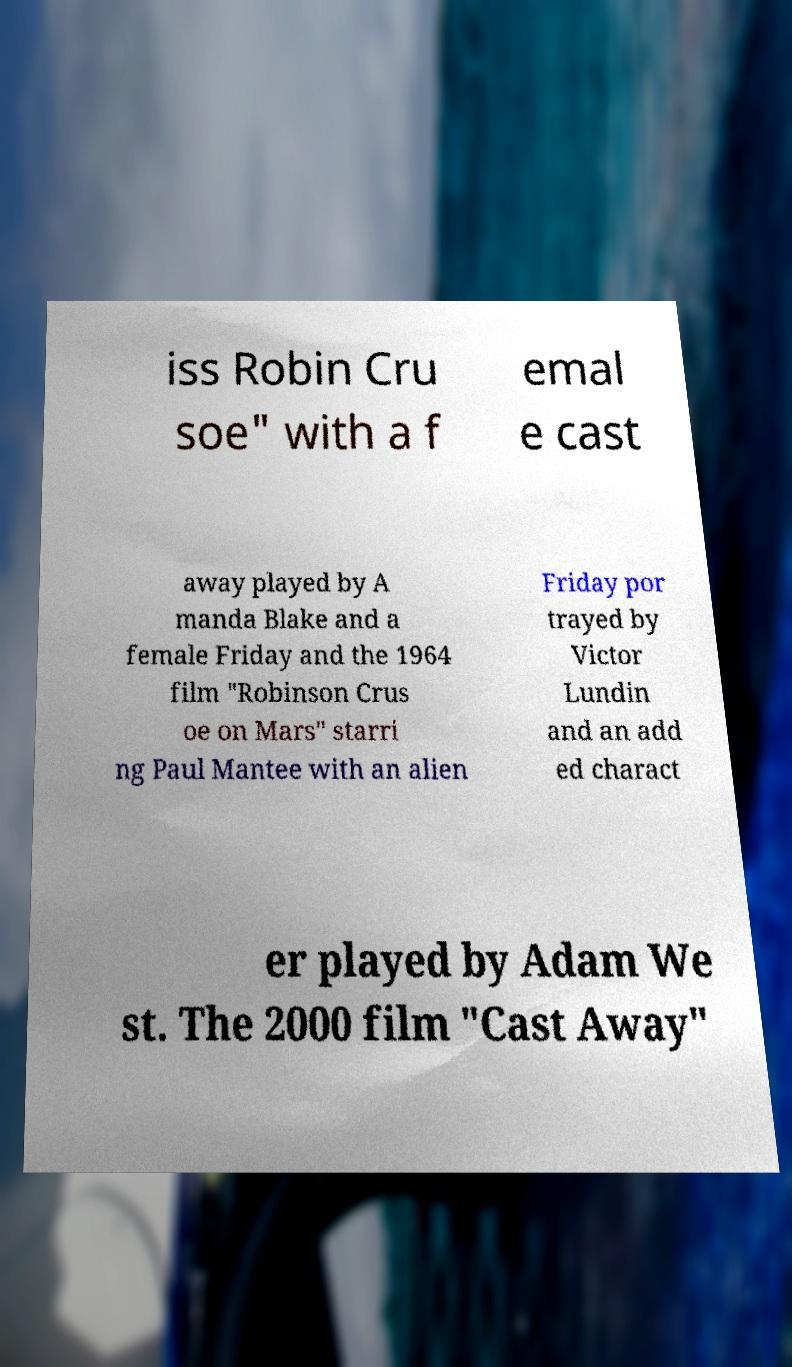Can you read and provide the text displayed in the image?This photo seems to have some interesting text. Can you extract and type it out for me? iss Robin Cru soe" with a f emal e cast away played by A manda Blake and a female Friday and the 1964 film "Robinson Crus oe on Mars" starri ng Paul Mantee with an alien Friday por trayed by Victor Lundin and an add ed charact er played by Adam We st. The 2000 film "Cast Away" 